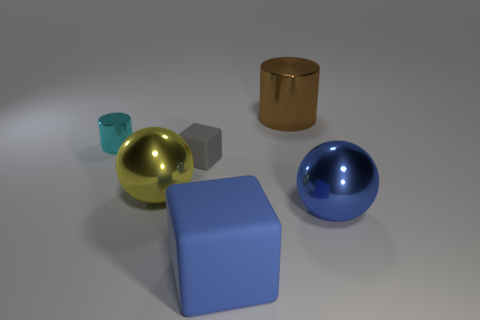Add 1 cyan rubber cylinders. How many objects exist? 7 Subtract all spheres. How many objects are left? 4 Add 5 small gray blocks. How many small gray blocks are left? 6 Add 2 small green things. How many small green things exist? 2 Subtract 0 yellow cylinders. How many objects are left? 6 Subtract all large yellow rubber cylinders. Subtract all big cylinders. How many objects are left? 5 